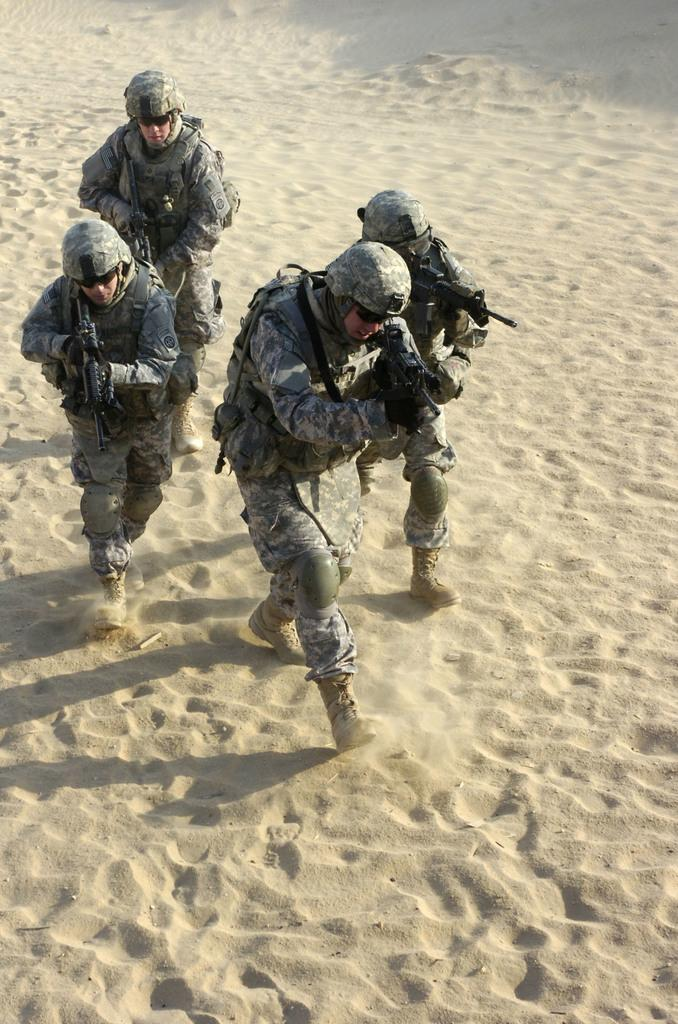How many people are in the image? There are four people in the image. What are the people wearing? The people are wearing military uniforms, helmets, and goggles. What are the people holding in their hands? The people are holding guns in their hands. Where are the people standing? The people are standing on the ground. What type of iron can be seen in the image? There is no iron present in the image. Is there any steam visible in the image? There is no steam visible in the image. 